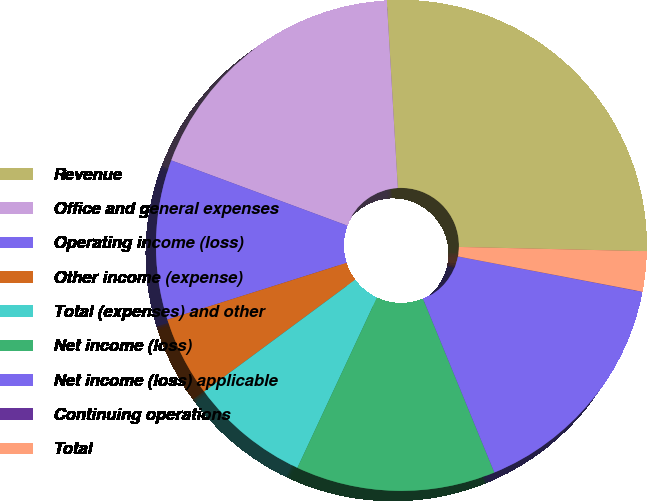Convert chart to OTSL. <chart><loc_0><loc_0><loc_500><loc_500><pie_chart><fcel>Revenue<fcel>Office and general expenses<fcel>Operating income (loss)<fcel>Other income (expense)<fcel>Total (expenses) and other<fcel>Net income (loss)<fcel>Net income (loss) applicable<fcel>Continuing operations<fcel>Total<nl><fcel>26.3%<fcel>18.42%<fcel>10.53%<fcel>5.27%<fcel>7.9%<fcel>13.16%<fcel>15.79%<fcel>0.01%<fcel>2.64%<nl></chart> 